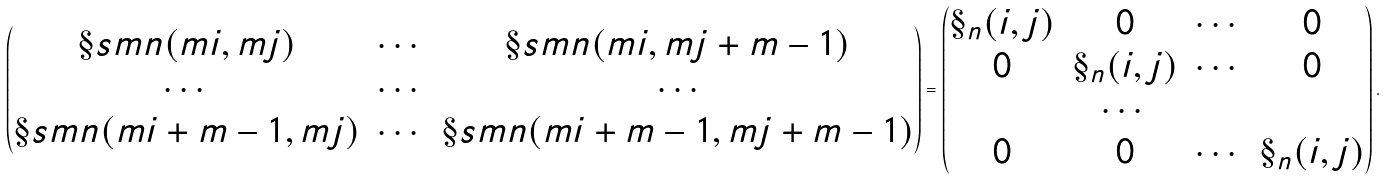Convert formula to latex. <formula><loc_0><loc_0><loc_500><loc_500>\begin{pmatrix} \S s m n ( m i , m j ) & \cdots & \S s m n ( m i , m j + m - 1 ) \\ \cdots & \cdots & \cdots \\ \S s m n ( m i + m - 1 , m j ) & \cdots & \S s m n ( m i + m - 1 , m j + m - 1 ) \end{pmatrix} = \begin{pmatrix} \S _ { n } ( i , j ) & 0 & \cdots & 0 \\ 0 & \S _ { n } ( i , j ) & \cdots & 0 \\ & \cdots & & \\ 0 & 0 & \cdots & \S _ { n } ( i , j ) \end{pmatrix} .</formula> 